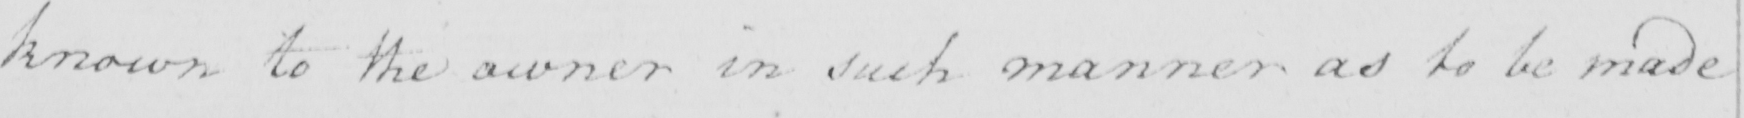Please transcribe the handwritten text in this image. known to the owner in such a manner as to be made 